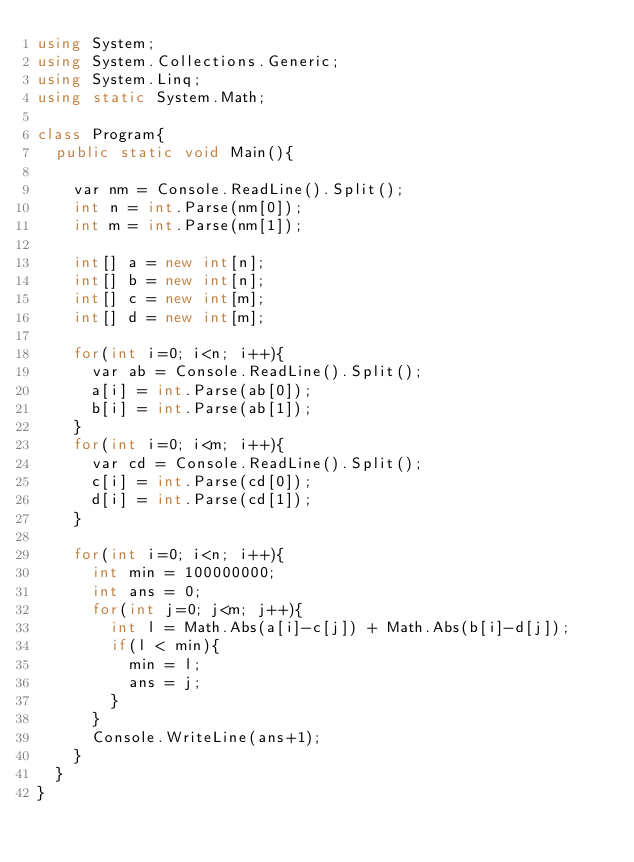Convert code to text. <code><loc_0><loc_0><loc_500><loc_500><_C#_>using System;
using System.Collections.Generic;
using System.Linq;
using static System.Math;

class Program{
  public static void Main(){

    var nm = Console.ReadLine().Split();
    int n = int.Parse(nm[0]);
    int m = int.Parse(nm[1]);
    
    int[] a = new int[n];
    int[] b = new int[n];
    int[] c = new int[m];
    int[] d = new int[m];
    
    for(int i=0; i<n; i++){
      var ab = Console.ReadLine().Split();
      a[i] = int.Parse(ab[0]);
      b[i] = int.Parse(ab[1]);
    }
    for(int i=0; i<m; i++){
      var cd = Console.ReadLine().Split();
      c[i] = int.Parse(cd[0]);
      d[i] = int.Parse(cd[1]);
    }
    
    for(int i=0; i<n; i++){
      int min = 100000000;
      int ans = 0;
      for(int j=0; j<m; j++){
        int l = Math.Abs(a[i]-c[j]) + Math.Abs(b[i]-d[j]);
        if(l < min){
          min = l;
          ans = j;
        }
      }
      Console.WriteLine(ans+1);
    }
  }
}</code> 